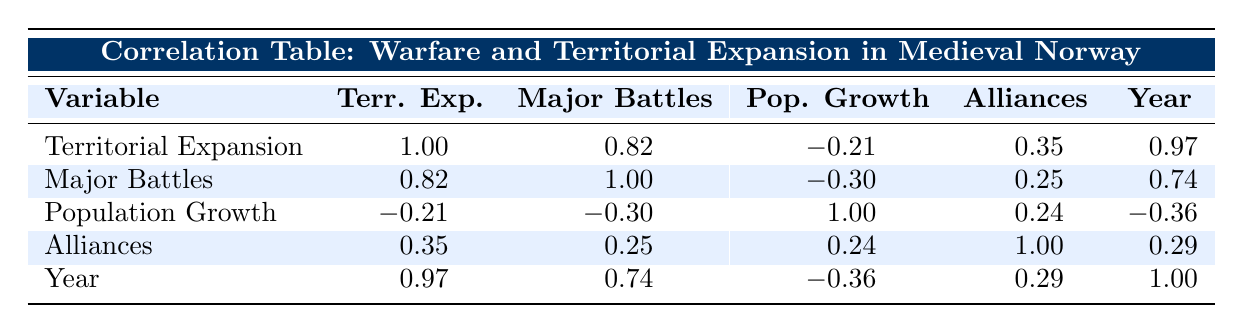What is the correlation coefficient between territorial expansion and major battles? According to the table, the correlation coefficient between territorial expansion and major battles is 0.82. This indicates a strong positive relationship between the two variables, meaning as territorial expansion increases, the number of major battles tends to increase as well.
Answer: 0.82 What year corresponds to the lowest population growth percentage? The population growth percentages for each year are listed, and the lowest percentage is 3, which corresponds to the year 1500.
Answer: 1500 What is the average number of major battles across the years listed in the table? To calculate the average, sum the number of major battles (2 + 3 + 4 + 5 + 6 + 4 + 7 + 5 = 36) and divide by the number of years (8). Therefore, the average is 36/8 = 4.5.
Answer: 4.5 Do alliances have a correlation coefficient higher than 0.3 with territorial expansion? Referring to the table, the correlation coefficient between alliances and territorial expansion is 0.35. Since 0.35 is higher than 0.3, the statement is true.
Answer: Yes What is the relationship between year and population growth based on the correlation coefficient? The correlation coefficient between year and population growth is -0.36. This indicates a weak negative correlation, suggesting that as time progresses, the population growth percentage tends to decline slightly.
Answer: Weak negative correlation 